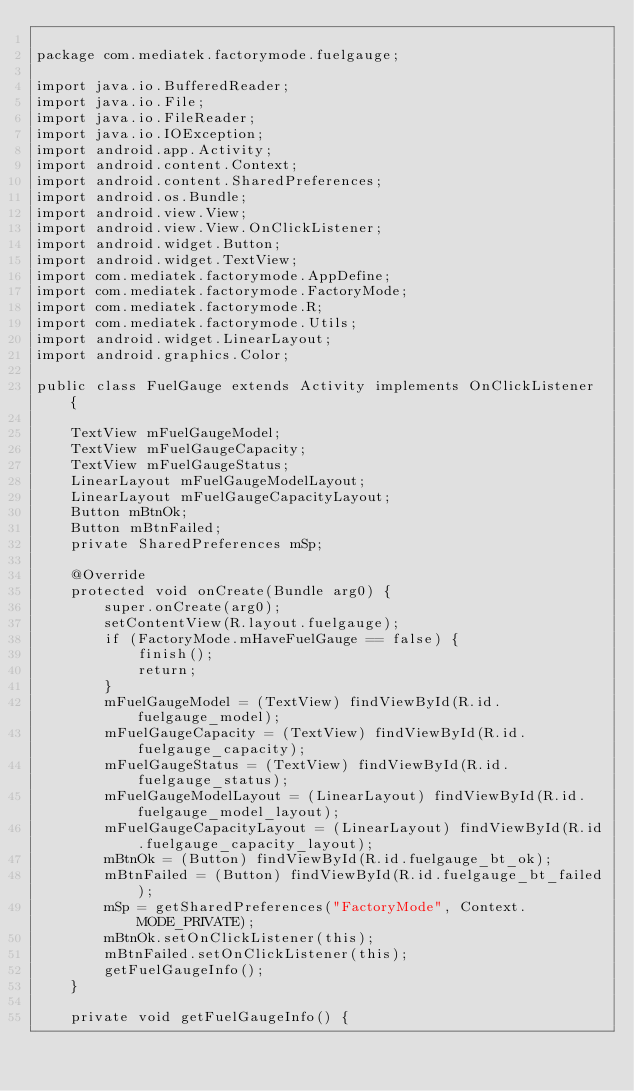<code> <loc_0><loc_0><loc_500><loc_500><_Java_>
package com.mediatek.factorymode.fuelgauge;

import java.io.BufferedReader;
import java.io.File;
import java.io.FileReader;
import java.io.IOException;
import android.app.Activity;
import android.content.Context;
import android.content.SharedPreferences;
import android.os.Bundle;
import android.view.View;
import android.view.View.OnClickListener;
import android.widget.Button;
import android.widget.TextView;
import com.mediatek.factorymode.AppDefine;
import com.mediatek.factorymode.FactoryMode;
import com.mediatek.factorymode.R;
import com.mediatek.factorymode.Utils;
import android.widget.LinearLayout;
import android.graphics.Color;

public class FuelGauge extends Activity implements OnClickListener {

    TextView mFuelGaugeModel;
    TextView mFuelGaugeCapacity;
    TextView mFuelGaugeStatus;
    LinearLayout mFuelGaugeModelLayout;
    LinearLayout mFuelGaugeCapacityLayout;
    Button mBtnOk;
    Button mBtnFailed;
    private SharedPreferences mSp;

    @Override
    protected void onCreate(Bundle arg0) {
        super.onCreate(arg0);
        setContentView(R.layout.fuelgauge);
        if (FactoryMode.mHaveFuelGauge == false) {
            finish();
            return;
        }
        mFuelGaugeModel = (TextView) findViewById(R.id.fuelgauge_model);
        mFuelGaugeCapacity = (TextView) findViewById(R.id.fuelgauge_capacity);
        mFuelGaugeStatus = (TextView) findViewById(R.id.fuelgauge_status);
        mFuelGaugeModelLayout = (LinearLayout) findViewById(R.id.fuelgauge_model_layout);
        mFuelGaugeCapacityLayout = (LinearLayout) findViewById(R.id.fuelgauge_capacity_layout);
        mBtnOk = (Button) findViewById(R.id.fuelgauge_bt_ok);
        mBtnFailed = (Button) findViewById(R.id.fuelgauge_bt_failed);
        mSp = getSharedPreferences("FactoryMode", Context.MODE_PRIVATE);
        mBtnOk.setOnClickListener(this);
        mBtnFailed.setOnClickListener(this);
        getFuelGaugeInfo();
    }

    private void getFuelGaugeInfo() {</code> 